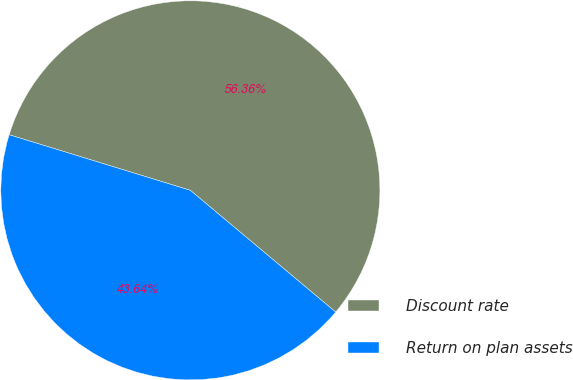Convert chart to OTSL. <chart><loc_0><loc_0><loc_500><loc_500><pie_chart><fcel>Discount rate<fcel>Return on plan assets<nl><fcel>56.36%<fcel>43.64%<nl></chart> 